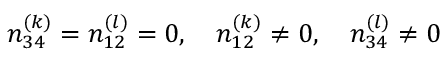Convert formula to latex. <formula><loc_0><loc_0><loc_500><loc_500>n _ { 3 4 } ^ { ( k ) } = n _ { 1 2 } ^ { ( l ) } = 0 , \quad n _ { 1 2 } ^ { ( k ) } \ne 0 , \quad n _ { 3 4 } ^ { ( l ) } \ne 0</formula> 